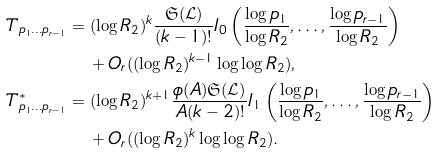Convert formula to latex. <formula><loc_0><loc_0><loc_500><loc_500>T _ { p _ { 1 } \dots p _ { r - 1 } } & = ( \log { R _ { 2 } } ) ^ { k } \frac { \mathfrak { S } ( \mathcal { L } ) } { ( k - 1 ) ! } I _ { 0 } \left ( \frac { \log { p _ { 1 } } } { \log { R _ { 2 } } } , \dots , \frac { \log { p _ { r - 1 } } } { \log { R _ { 2 } } } \right ) \\ & \quad + O _ { r } ( ( \log { R _ { 2 } } ) ^ { k - 1 } \log \log { R _ { 2 } } ) , \\ T _ { p _ { 1 } \dots p _ { r - 1 } } ^ { * } & = ( \log { R _ { 2 } } ) ^ { k + 1 } \frac { \phi ( A ) \mathfrak { S } ( \mathcal { L } ) } { A ( k - 2 ) ! } I _ { 1 } \left ( \frac { \log { p _ { 1 } } } { \log { R _ { 2 } } } , \dots , \frac { \log { p _ { r - 1 } } } { \log { R _ { 2 } } } \right ) \\ & \quad + O _ { r } ( ( \log { R _ { 2 } } ) ^ { k } \log \log { R _ { 2 } } ) .</formula> 